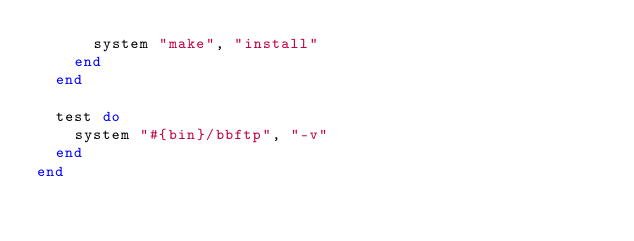Convert code to text. <code><loc_0><loc_0><loc_500><loc_500><_Ruby_>      system "make", "install"
    end
  end

  test do
    system "#{bin}/bbftp", "-v"
  end
end
</code> 